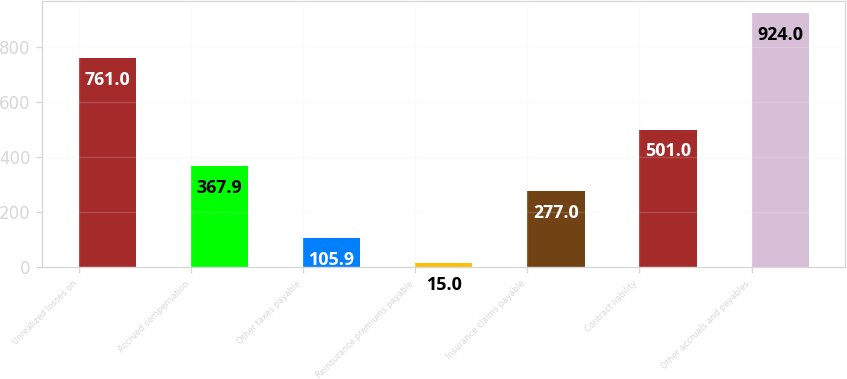<chart> <loc_0><loc_0><loc_500><loc_500><bar_chart><fcel>Unrealized losses on<fcel>Accrued compensation<fcel>Other taxes payable<fcel>Reinsurance premiums payable<fcel>Insurance claims payable<fcel>Contract liability<fcel>Other accruals and payables<nl><fcel>761<fcel>367.9<fcel>105.9<fcel>15<fcel>277<fcel>501<fcel>924<nl></chart> 